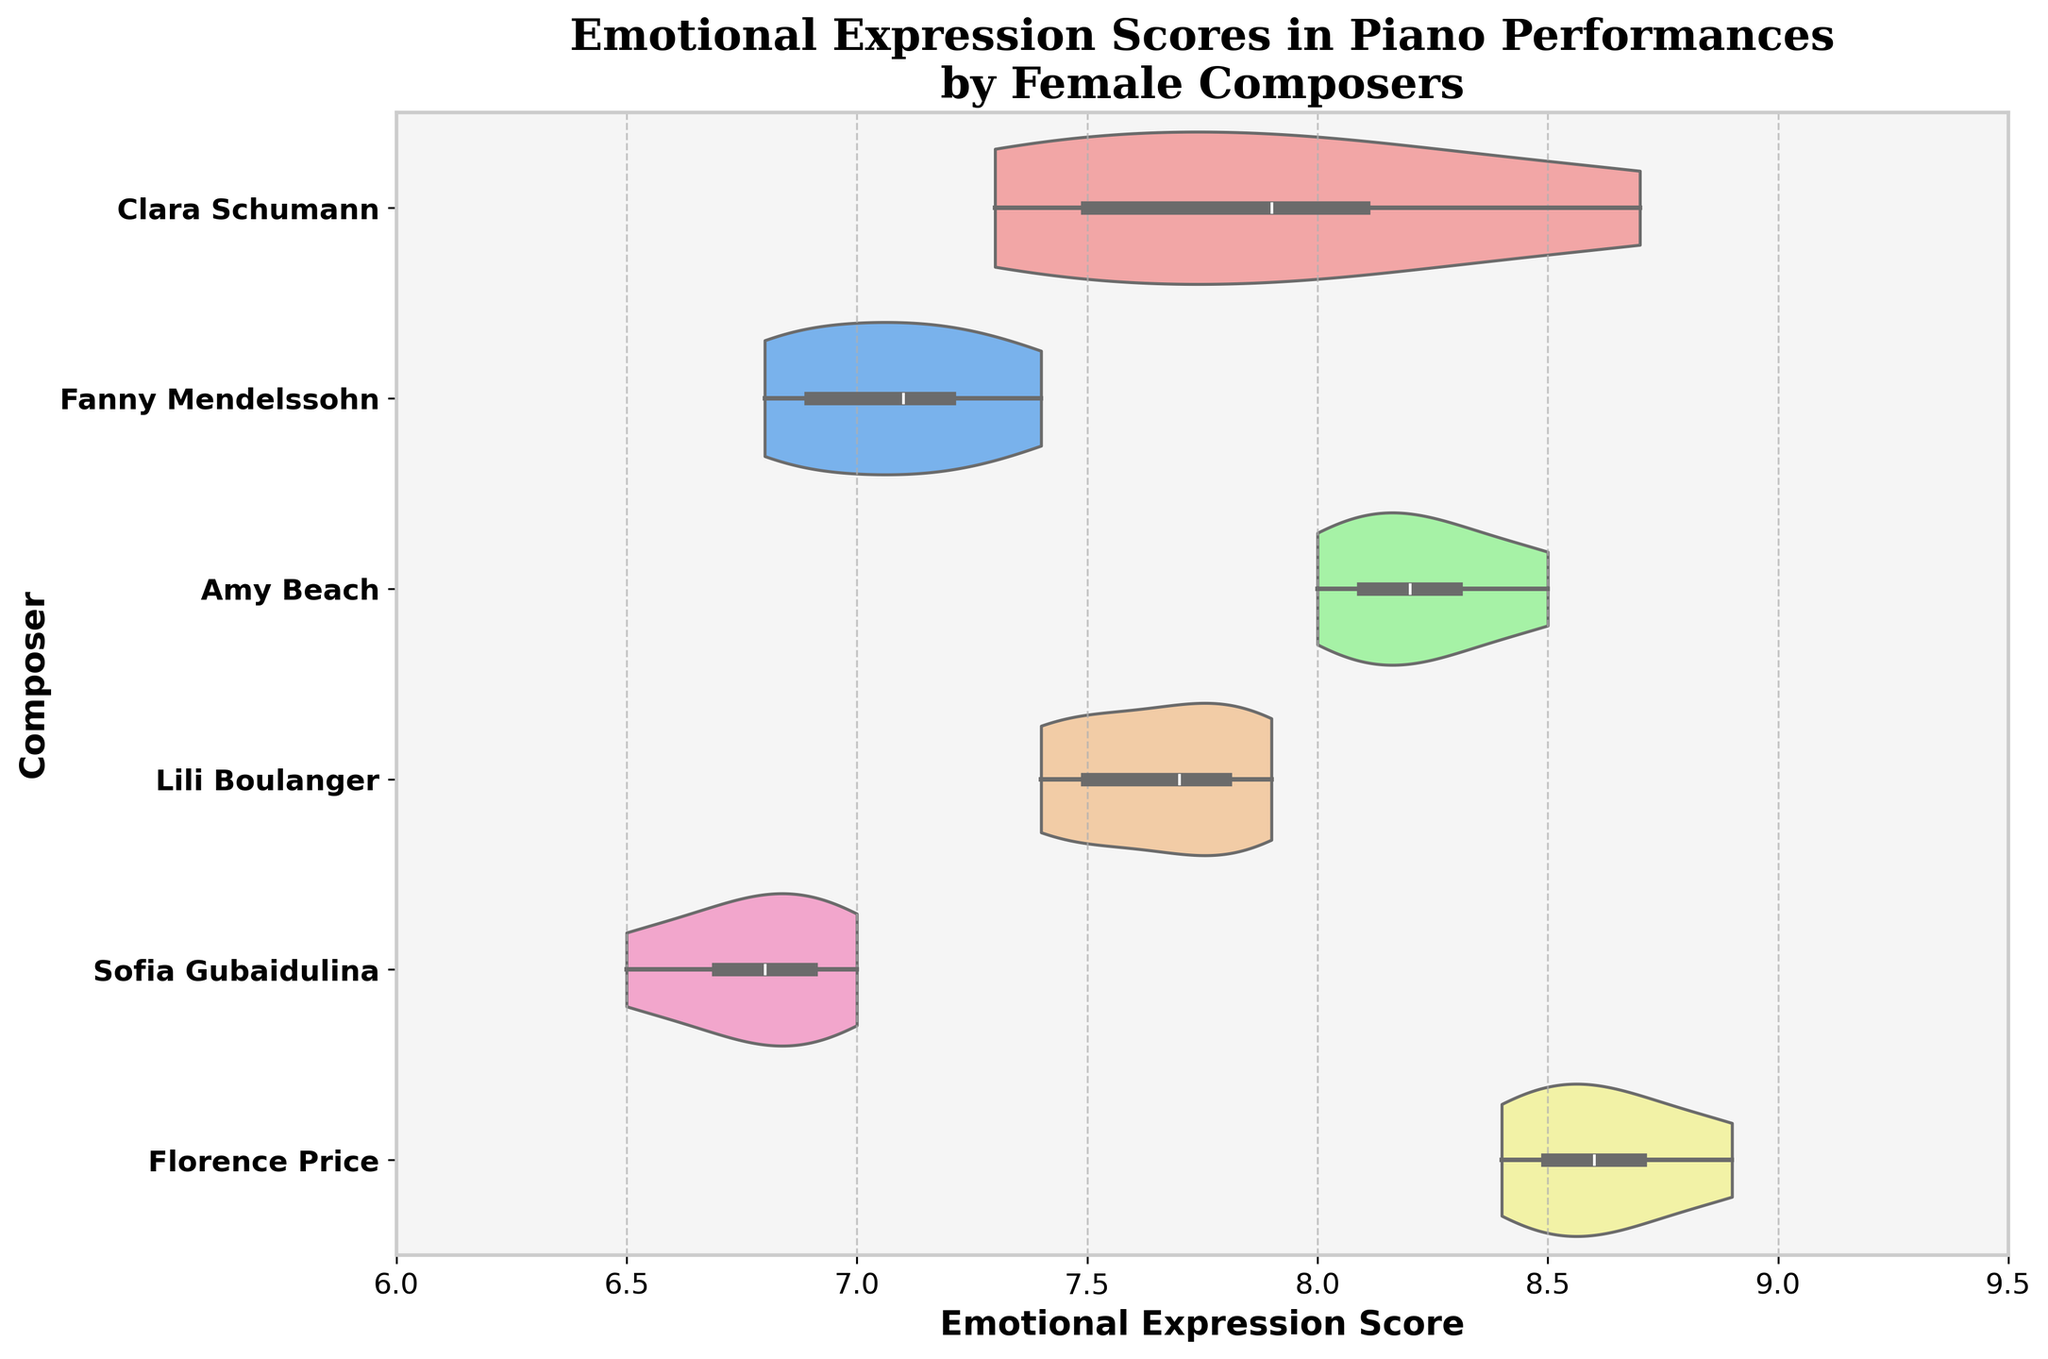What is the title of the plot? The title is prominently displayed at the top of the plot.
Answer: Emotional Expression Scores in Piano Performances by Female Composers Which composer has the highest median Emotional Expression Score? The composer with the highest median score will appear with the central white dot (median) on the x-axis further to the right compared to others.
Answer: Florence Price What is the range of Emotional Expression Scores for Amy Beach? The range can be determined by finding the minimum and maximum points within Amy Beach's violin plot, located on the x-axis.
Answer: 8.0 to 8.5 How does the variation in Emotional Expression Scores for Sofia Gubaidulina compare to Clara Schumann? Sofia Gubaidulina's scores appear more varied (wider filling) than Clara Schumann's, which can be observed by comparing the width of their respective violin plots.
Answer: Sofia Gubaidulina shows less variation than Clara Schumann Between Fanny Mendelssohn and Lili Boulanger, who has a higher maximum Emotional Expression Score? By comparing the upper ends of the violin plots for Fanny Mendelssohn and Lili Boulanger, we can determine which is higher.
Answer: Fanny Mendelssohn What is the approximate median Emotional Expression Score for Lili Boulanger? The median is indicated by the white dot within the box of Lili Boulanger's violin plot, which can be read directly from the x-axis.
Answer: Approximately 7.5 Which composer shows the widest spread of Emotional Expression Scores? The composer with the violin plot that spans the largest range on the x-axis demonstrates the widest spread.
Answer: Florence Price How do the Emotional Expression Scores of Clara Schumann and Amy Beach compare? Comparing the position and spread of both violin plots, Clara Schumann has a wide spread, while Amy Beach's scores are more clustered around a higher central value.
Answer: Clara Schumann's scores are more varied, Amy Beach's are higher and clustered What is the average Emotional Expression Score for Florence Price? Calculate the average by summing the scores for Florence Price (8.4 + 8.6 + 8.9 + 8.7 + 8.5) and dividing by the number of scores (5).
Answer: 8.62 Which composer has the lowest Emotional Expression Score? Identifying the composer with the lowest minimum score on the x-axis will give the answer.
Answer: Sofia Gubaidulina 